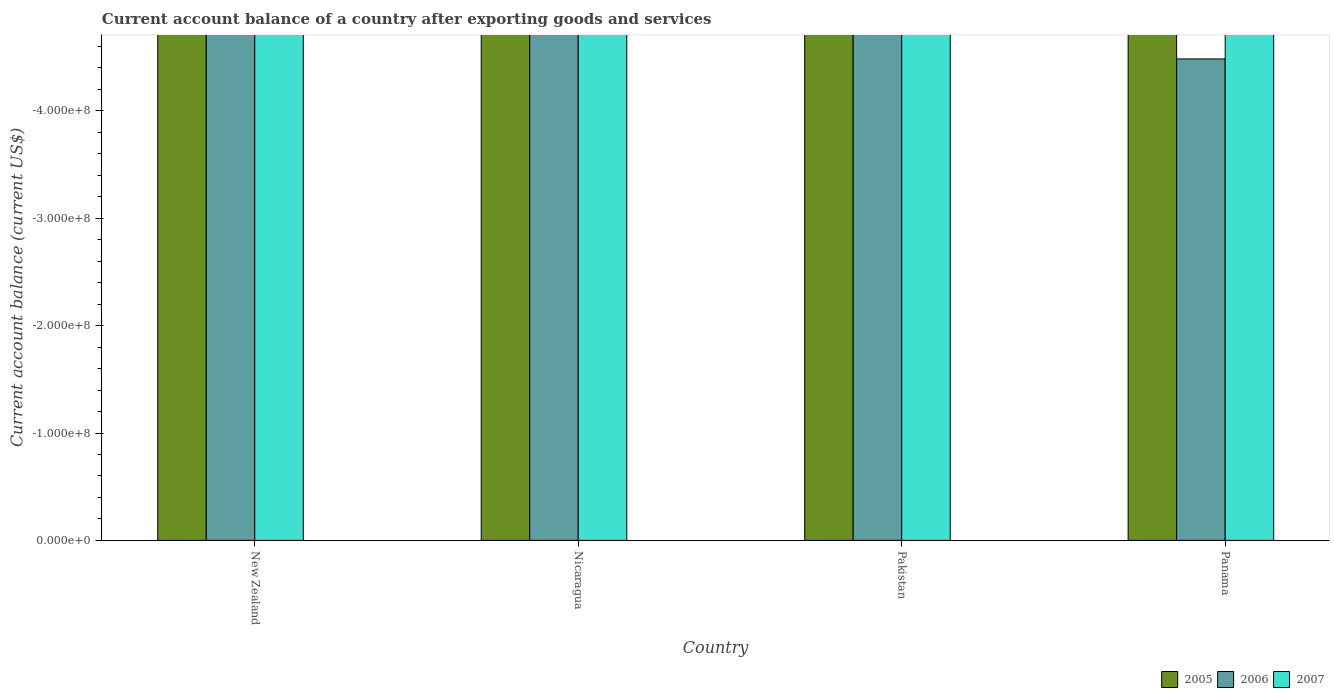How many different coloured bars are there?
Keep it short and to the point. 0. How many bars are there on the 4th tick from the right?
Provide a succinct answer. 0. What is the label of the 1st group of bars from the left?
Offer a very short reply. New Zealand. What is the total account balance in 2006 in the graph?
Your answer should be compact. 0. What is the average account balance in 2005 per country?
Your answer should be compact. 0. In how many countries, is the account balance in 2007 greater than -180000000 US$?
Your response must be concise. 0. In how many countries, is the account balance in 2005 greater than the average account balance in 2005 taken over all countries?
Give a very brief answer. 0. Is it the case that in every country, the sum of the account balance in 2006 and account balance in 2005 is greater than the account balance in 2007?
Provide a succinct answer. No. How many bars are there?
Offer a very short reply. 0. Are all the bars in the graph horizontal?
Provide a short and direct response. No. What is the difference between two consecutive major ticks on the Y-axis?
Offer a very short reply. 1.00e+08. Does the graph contain any zero values?
Provide a short and direct response. Yes. Does the graph contain grids?
Make the answer very short. No. What is the title of the graph?
Ensure brevity in your answer.  Current account balance of a country after exporting goods and services. What is the label or title of the Y-axis?
Your answer should be compact. Current account balance (current US$). What is the Current account balance (current US$) of 2005 in New Zealand?
Keep it short and to the point. 0. What is the Current account balance (current US$) in 2005 in Nicaragua?
Keep it short and to the point. 0. What is the Current account balance (current US$) of 2006 in Nicaragua?
Keep it short and to the point. 0. What is the Current account balance (current US$) of 2007 in Nicaragua?
Give a very brief answer. 0. What is the Current account balance (current US$) in 2006 in Pakistan?
Offer a terse response. 0. What is the total Current account balance (current US$) of 2005 in the graph?
Make the answer very short. 0. What is the average Current account balance (current US$) in 2006 per country?
Your answer should be very brief. 0. What is the average Current account balance (current US$) in 2007 per country?
Offer a very short reply. 0. 